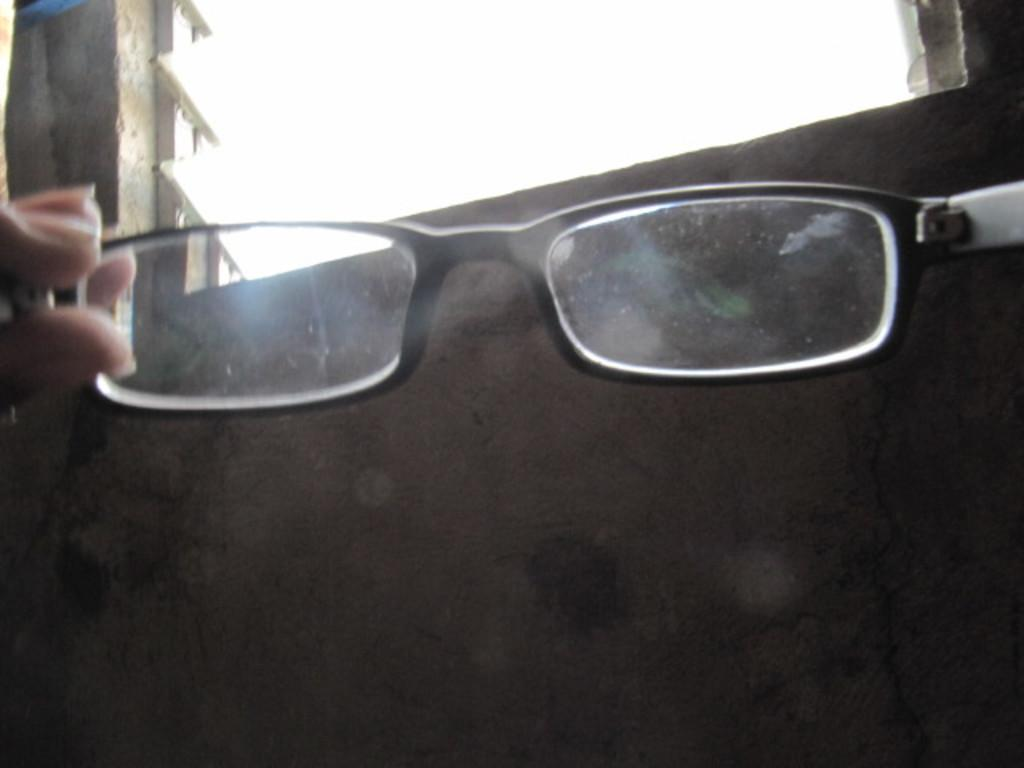What is the main object in the center of the image? There is a pair of spectacles in the center of the image. What can be seen at the top side of the image? There is a window at the top side of the image. How many friends are visible in the image? There are no friends visible in the image; it only features a pair of spectacles and a window. What type of pigs can be seen in the image? There are no pigs present in the image. 